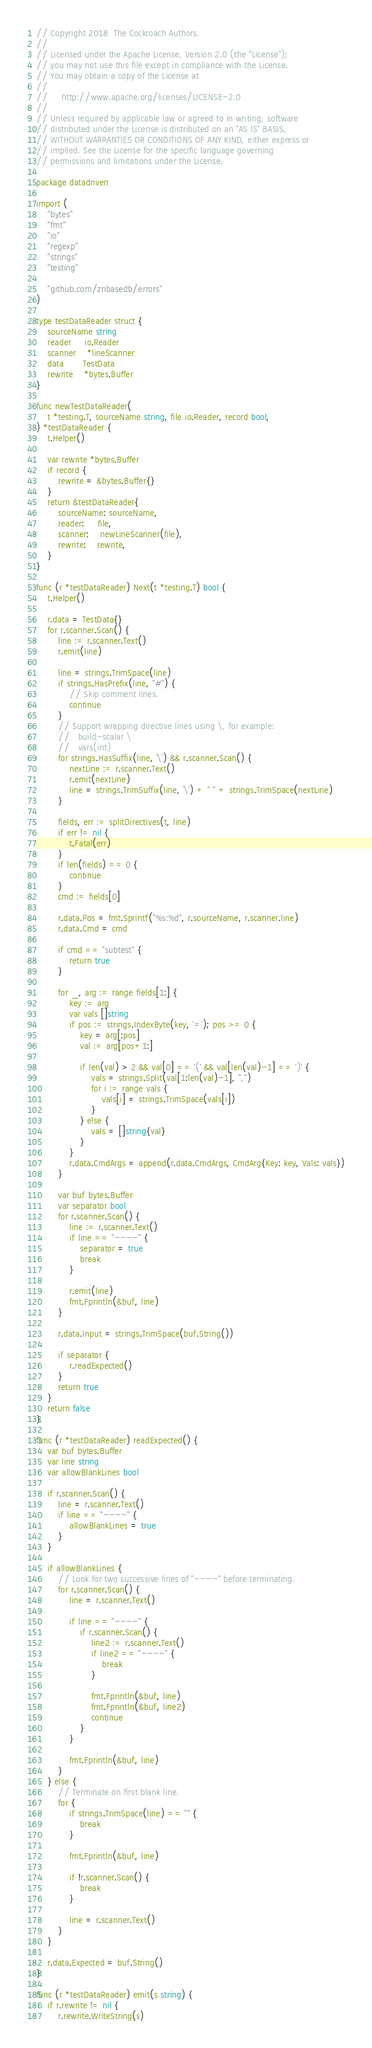<code> <loc_0><loc_0><loc_500><loc_500><_Go_>// Copyright 2018  The Cockroach Authors.
//
// Licensed under the Apache License, Version 2.0 (the "License");
// you may not use this file except in compliance with the License.
// You may obtain a copy of the License at
//
//     http://www.apache.org/licenses/LICENSE-2.0
//
// Unless required by applicable law or agreed to in writing, software
// distributed under the License is distributed on an "AS IS" BASIS,
// WITHOUT WARRANTIES OR CONDITIONS OF ANY KIND, either express or
// implied. See the License for the specific language governing
// permissions and limitations under the License.

package datadriven

import (
	"bytes"
	"fmt"
	"io"
	"regexp"
	"strings"
	"testing"

	"github.com/znbasedb/errors"
)

type testDataReader struct {
	sourceName string
	reader     io.Reader
	scanner    *lineScanner
	data       TestData
	rewrite    *bytes.Buffer
}

func newTestDataReader(
	t *testing.T, sourceName string, file io.Reader, record bool,
) *testDataReader {
	t.Helper()

	var rewrite *bytes.Buffer
	if record {
		rewrite = &bytes.Buffer{}
	}
	return &testDataReader{
		sourceName: sourceName,
		reader:     file,
		scanner:    newLineScanner(file),
		rewrite:    rewrite,
	}
}

func (r *testDataReader) Next(t *testing.T) bool {
	t.Helper()

	r.data = TestData{}
	for r.scanner.Scan() {
		line := r.scanner.Text()
		r.emit(line)

		line = strings.TrimSpace(line)
		if strings.HasPrefix(line, "#") {
			// Skip comment lines.
			continue
		}
		// Support wrapping directive lines using \, for example:
		//   build-scalar \
		//   vars(int)
		for strings.HasSuffix(line, `\`) && r.scanner.Scan() {
			nextLine := r.scanner.Text()
			r.emit(nextLine)
			line = strings.TrimSuffix(line, `\`) + " " + strings.TrimSpace(nextLine)
		}

		fields, err := splitDirectives(t, line)
		if err != nil {
			t.Fatal(err)
		}
		if len(fields) == 0 {
			continue
		}
		cmd := fields[0]

		r.data.Pos = fmt.Sprintf("%s:%d", r.sourceName, r.scanner.line)
		r.data.Cmd = cmd

		if cmd == "subtest" {
			return true
		}

		for _, arg := range fields[1:] {
			key := arg
			var vals []string
			if pos := strings.IndexByte(key, '='); pos >= 0 {
				key = arg[:pos]
				val := arg[pos+1:]

				if len(val) > 2 && val[0] == '(' && val[len(val)-1] == ')' {
					vals = strings.Split(val[1:len(val)-1], ",")
					for i := range vals {
						vals[i] = strings.TrimSpace(vals[i])
					}
				} else {
					vals = []string{val}
				}
			}
			r.data.CmdArgs = append(r.data.CmdArgs, CmdArg{Key: key, Vals: vals})
		}

		var buf bytes.Buffer
		var separator bool
		for r.scanner.Scan() {
			line := r.scanner.Text()
			if line == "----" {
				separator = true
				break
			}

			r.emit(line)
			fmt.Fprintln(&buf, line)
		}

		r.data.Input = strings.TrimSpace(buf.String())

		if separator {
			r.readExpected()
		}
		return true
	}
	return false
}

func (r *testDataReader) readExpected() {
	var buf bytes.Buffer
	var line string
	var allowBlankLines bool

	if r.scanner.Scan() {
		line = r.scanner.Text()
		if line == "----" {
			allowBlankLines = true
		}
	}

	if allowBlankLines {
		// Look for two successive lines of "----" before terminating.
		for r.scanner.Scan() {
			line = r.scanner.Text()

			if line == "----" {
				if r.scanner.Scan() {
					line2 := r.scanner.Text()
					if line2 == "----" {
						break
					}

					fmt.Fprintln(&buf, line)
					fmt.Fprintln(&buf, line2)
					continue
				}
			}

			fmt.Fprintln(&buf, line)
		}
	} else {
		// Terminate on first blank line.
		for {
			if strings.TrimSpace(line) == "" {
				break
			}

			fmt.Fprintln(&buf, line)

			if !r.scanner.Scan() {
				break
			}

			line = r.scanner.Text()
		}
	}

	r.data.Expected = buf.String()
}

func (r *testDataReader) emit(s string) {
	if r.rewrite != nil {
		r.rewrite.WriteString(s)</code> 